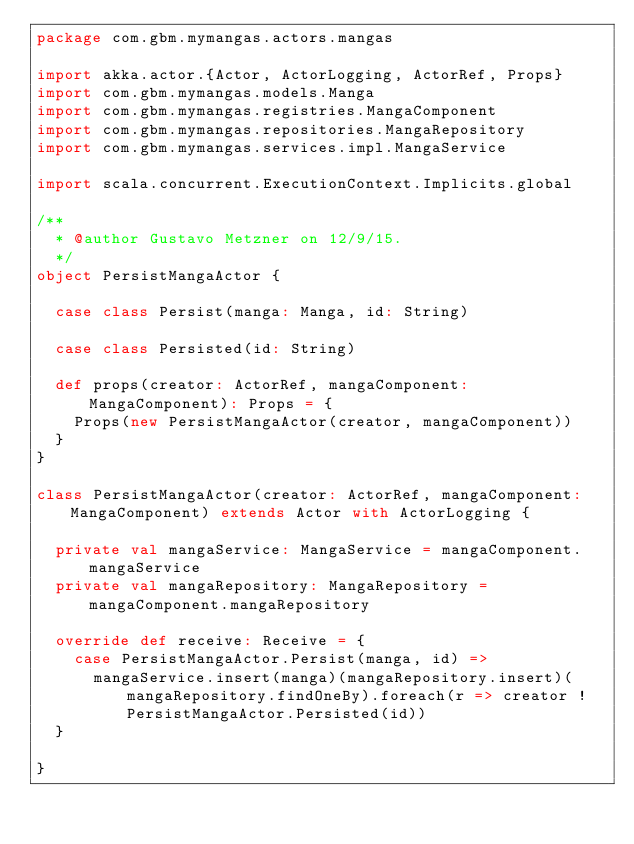<code> <loc_0><loc_0><loc_500><loc_500><_Scala_>package com.gbm.mymangas.actors.mangas

import akka.actor.{Actor, ActorLogging, ActorRef, Props}
import com.gbm.mymangas.models.Manga
import com.gbm.mymangas.registries.MangaComponent
import com.gbm.mymangas.repositories.MangaRepository
import com.gbm.mymangas.services.impl.MangaService

import scala.concurrent.ExecutionContext.Implicits.global

/**
  * @author Gustavo Metzner on 12/9/15.
  */
object PersistMangaActor {

  case class Persist(manga: Manga, id: String)

  case class Persisted(id: String)

  def props(creator: ActorRef, mangaComponent: MangaComponent): Props = {
    Props(new PersistMangaActor(creator, mangaComponent))
  }
}

class PersistMangaActor(creator: ActorRef, mangaComponent: MangaComponent) extends Actor with ActorLogging {

  private val mangaService: MangaService = mangaComponent.mangaService
  private val mangaRepository: MangaRepository = mangaComponent.mangaRepository

  override def receive: Receive = {
    case PersistMangaActor.Persist(manga, id) =>
      mangaService.insert(manga)(mangaRepository.insert)(mangaRepository.findOneBy).foreach(r => creator ! PersistMangaActor.Persisted(id))
  }

}
</code> 